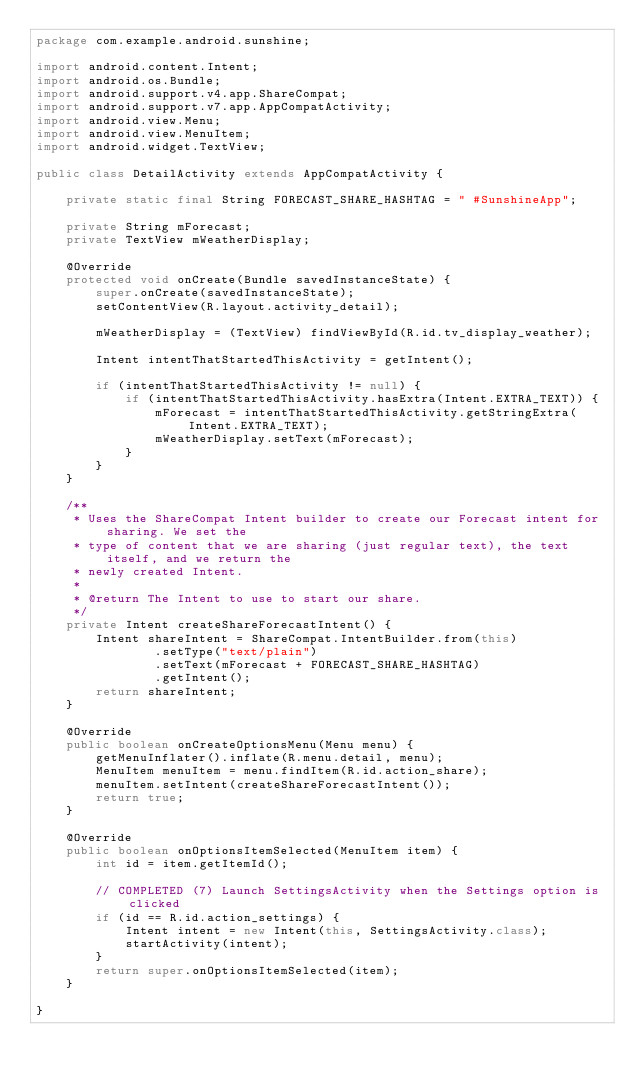Convert code to text. <code><loc_0><loc_0><loc_500><loc_500><_Java_>package com.example.android.sunshine;

import android.content.Intent;
import android.os.Bundle;
import android.support.v4.app.ShareCompat;
import android.support.v7.app.AppCompatActivity;
import android.view.Menu;
import android.view.MenuItem;
import android.widget.TextView;

public class DetailActivity extends AppCompatActivity {

    private static final String FORECAST_SHARE_HASHTAG = " #SunshineApp";

    private String mForecast;
    private TextView mWeatherDisplay;

    @Override
    protected void onCreate(Bundle savedInstanceState) {
        super.onCreate(savedInstanceState);
        setContentView(R.layout.activity_detail);

        mWeatherDisplay = (TextView) findViewById(R.id.tv_display_weather);

        Intent intentThatStartedThisActivity = getIntent();

        if (intentThatStartedThisActivity != null) {
            if (intentThatStartedThisActivity.hasExtra(Intent.EXTRA_TEXT)) {
                mForecast = intentThatStartedThisActivity.getStringExtra(Intent.EXTRA_TEXT);
                mWeatherDisplay.setText(mForecast);
            }
        }
    }

    /**
     * Uses the ShareCompat Intent builder to create our Forecast intent for sharing. We set the
     * type of content that we are sharing (just regular text), the text itself, and we return the
     * newly created Intent.
     *
     * @return The Intent to use to start our share.
     */
    private Intent createShareForecastIntent() {
        Intent shareIntent = ShareCompat.IntentBuilder.from(this)
                .setType("text/plain")
                .setText(mForecast + FORECAST_SHARE_HASHTAG)
                .getIntent();
        return shareIntent;
    }

    @Override
    public boolean onCreateOptionsMenu(Menu menu) {
        getMenuInflater().inflate(R.menu.detail, menu);
        MenuItem menuItem = menu.findItem(R.id.action_share);
        menuItem.setIntent(createShareForecastIntent());
        return true;
    }

    @Override
    public boolean onOptionsItemSelected(MenuItem item) {
        int id = item.getItemId();

        // COMPLETED (7) Launch SettingsActivity when the Settings option is clicked
        if (id == R.id.action_settings) {
            Intent intent = new Intent(this, SettingsActivity.class);
            startActivity(intent);
        }
        return super.onOptionsItemSelected(item);
    }

}</code> 